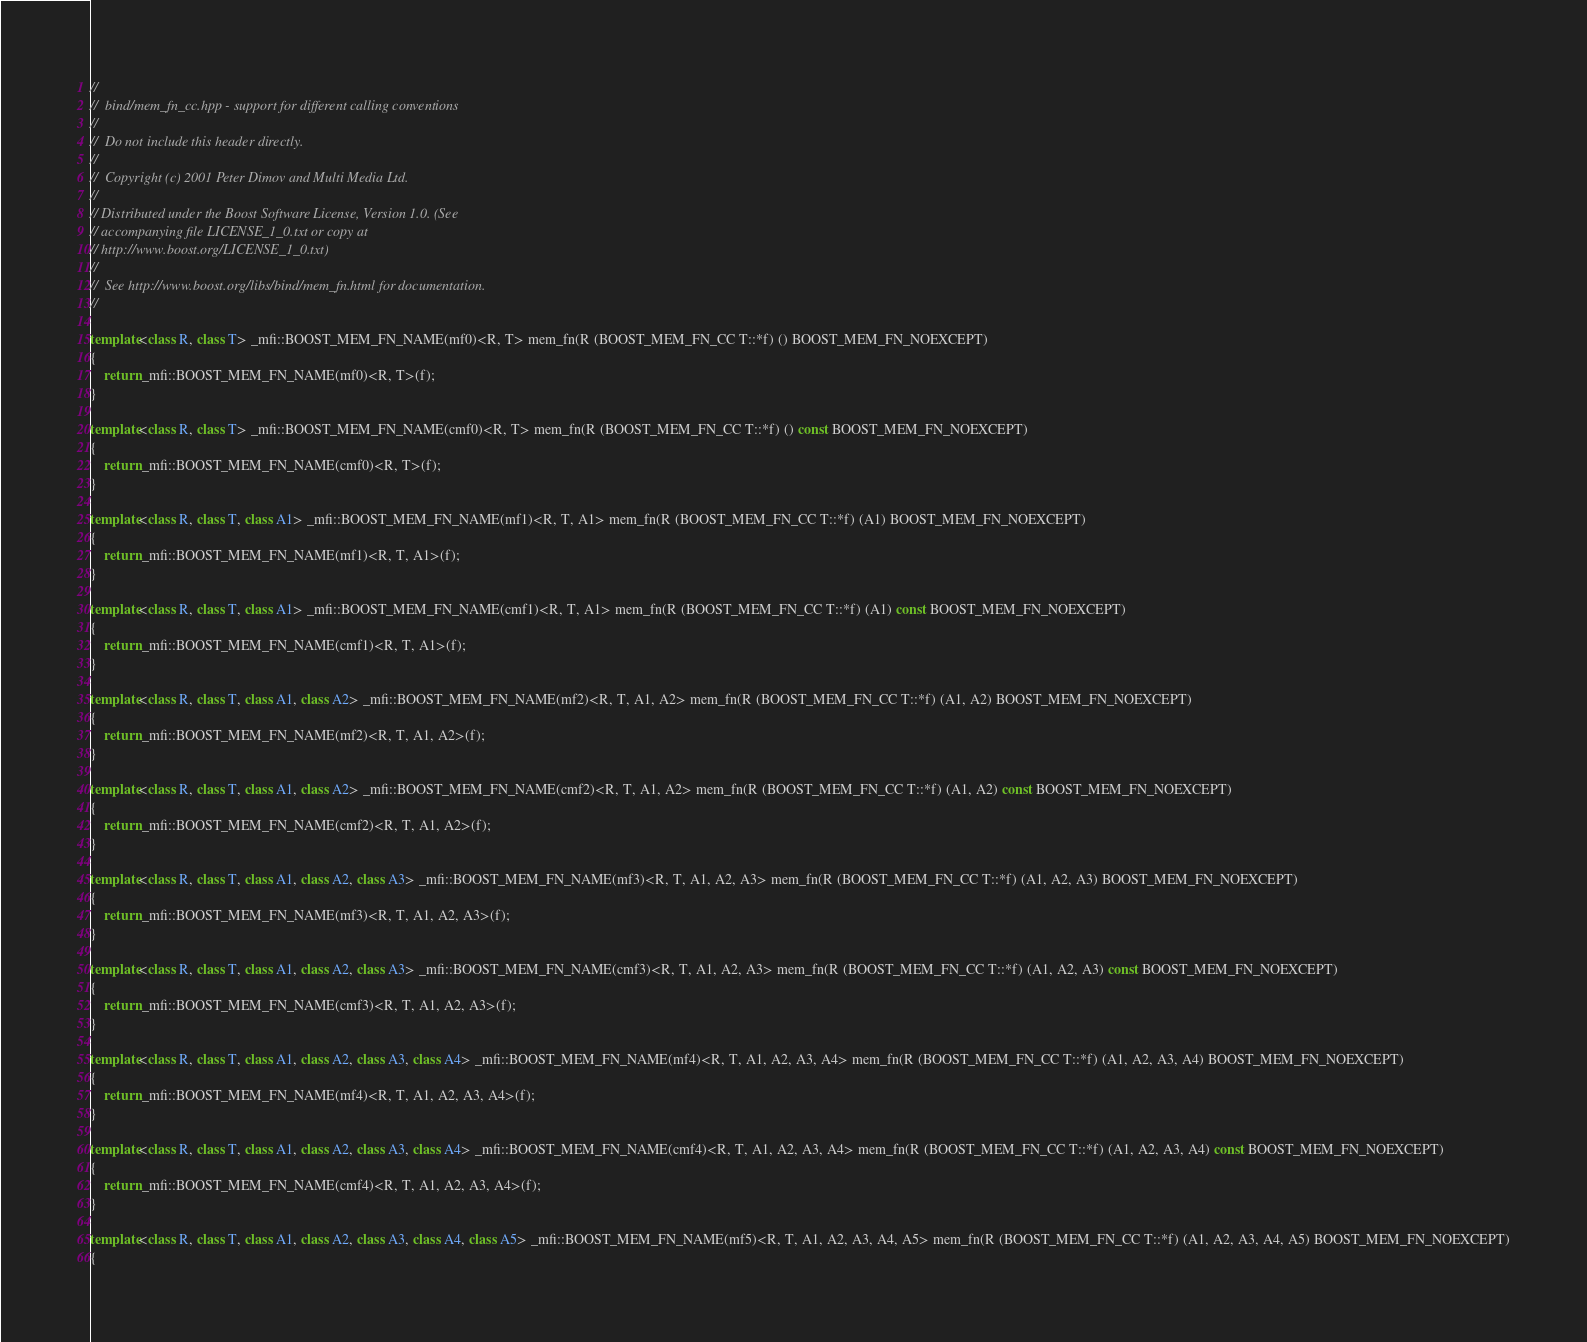<code> <loc_0><loc_0><loc_500><loc_500><_C++_>//
//  bind/mem_fn_cc.hpp - support for different calling conventions
//
//  Do not include this header directly.
//
//  Copyright (c) 2001 Peter Dimov and Multi Media Ltd.
//
// Distributed under the Boost Software License, Version 1.0. (See
// accompanying file LICENSE_1_0.txt or copy at
// http://www.boost.org/LICENSE_1_0.txt)
//
//  See http://www.boost.org/libs/bind/mem_fn.html for documentation.
//

template<class R, class T> _mfi::BOOST_MEM_FN_NAME(mf0)<R, T> mem_fn(R (BOOST_MEM_FN_CC T::*f) () BOOST_MEM_FN_NOEXCEPT)
{
    return _mfi::BOOST_MEM_FN_NAME(mf0)<R, T>(f);
}

template<class R, class T> _mfi::BOOST_MEM_FN_NAME(cmf0)<R, T> mem_fn(R (BOOST_MEM_FN_CC T::*f) () const BOOST_MEM_FN_NOEXCEPT)
{
    return _mfi::BOOST_MEM_FN_NAME(cmf0)<R, T>(f);
}

template<class R, class T, class A1> _mfi::BOOST_MEM_FN_NAME(mf1)<R, T, A1> mem_fn(R (BOOST_MEM_FN_CC T::*f) (A1) BOOST_MEM_FN_NOEXCEPT)
{
    return _mfi::BOOST_MEM_FN_NAME(mf1)<R, T, A1>(f);
}

template<class R, class T, class A1> _mfi::BOOST_MEM_FN_NAME(cmf1)<R, T, A1> mem_fn(R (BOOST_MEM_FN_CC T::*f) (A1) const BOOST_MEM_FN_NOEXCEPT)
{
    return _mfi::BOOST_MEM_FN_NAME(cmf1)<R, T, A1>(f);
}

template<class R, class T, class A1, class A2> _mfi::BOOST_MEM_FN_NAME(mf2)<R, T, A1, A2> mem_fn(R (BOOST_MEM_FN_CC T::*f) (A1, A2) BOOST_MEM_FN_NOEXCEPT)
{
    return _mfi::BOOST_MEM_FN_NAME(mf2)<R, T, A1, A2>(f);
}

template<class R, class T, class A1, class A2> _mfi::BOOST_MEM_FN_NAME(cmf2)<R, T, A1, A2> mem_fn(R (BOOST_MEM_FN_CC T::*f) (A1, A2) const BOOST_MEM_FN_NOEXCEPT)
{
    return _mfi::BOOST_MEM_FN_NAME(cmf2)<R, T, A1, A2>(f);
}

template<class R, class T, class A1, class A2, class A3> _mfi::BOOST_MEM_FN_NAME(mf3)<R, T, A1, A2, A3> mem_fn(R (BOOST_MEM_FN_CC T::*f) (A1, A2, A3) BOOST_MEM_FN_NOEXCEPT)
{
    return _mfi::BOOST_MEM_FN_NAME(mf3)<R, T, A1, A2, A3>(f);
}

template<class R, class T, class A1, class A2, class A3> _mfi::BOOST_MEM_FN_NAME(cmf3)<R, T, A1, A2, A3> mem_fn(R (BOOST_MEM_FN_CC T::*f) (A1, A2, A3) const BOOST_MEM_FN_NOEXCEPT)
{
    return _mfi::BOOST_MEM_FN_NAME(cmf3)<R, T, A1, A2, A3>(f);
}

template<class R, class T, class A1, class A2, class A3, class A4> _mfi::BOOST_MEM_FN_NAME(mf4)<R, T, A1, A2, A3, A4> mem_fn(R (BOOST_MEM_FN_CC T::*f) (A1, A2, A3, A4) BOOST_MEM_FN_NOEXCEPT)
{
    return _mfi::BOOST_MEM_FN_NAME(mf4)<R, T, A1, A2, A3, A4>(f);
}

template<class R, class T, class A1, class A2, class A3, class A4> _mfi::BOOST_MEM_FN_NAME(cmf4)<R, T, A1, A2, A3, A4> mem_fn(R (BOOST_MEM_FN_CC T::*f) (A1, A2, A3, A4) const BOOST_MEM_FN_NOEXCEPT)
{
    return _mfi::BOOST_MEM_FN_NAME(cmf4)<R, T, A1, A2, A3, A4>(f);
}

template<class R, class T, class A1, class A2, class A3, class A4, class A5> _mfi::BOOST_MEM_FN_NAME(mf5)<R, T, A1, A2, A3, A4, A5> mem_fn(R (BOOST_MEM_FN_CC T::*f) (A1, A2, A3, A4, A5) BOOST_MEM_FN_NOEXCEPT)
{</code> 